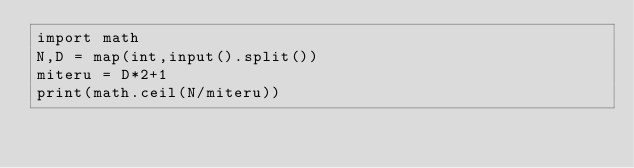<code> <loc_0><loc_0><loc_500><loc_500><_Python_>import math
N,D = map(int,input().split())
miteru = D*2+1
print(math.ceil(N/miteru))</code> 